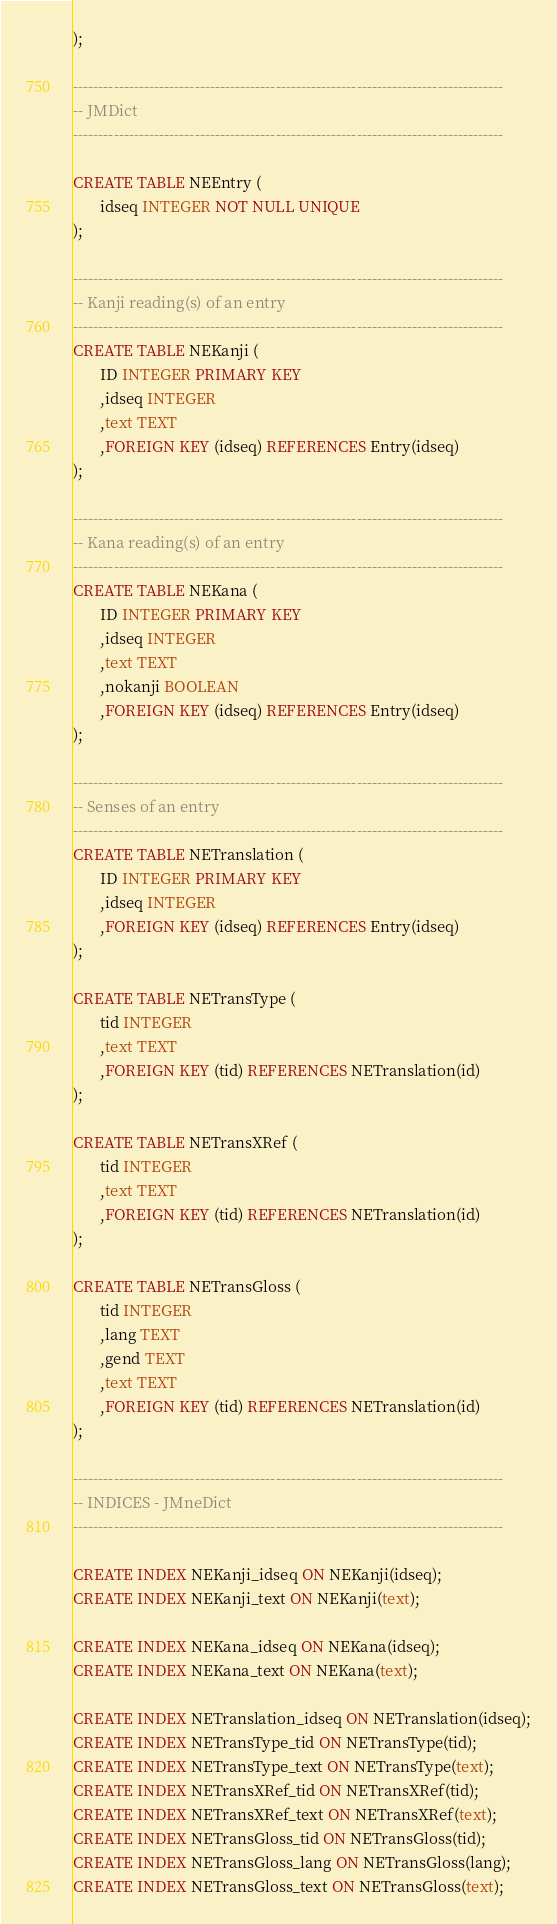Convert code to text. <code><loc_0><loc_0><loc_500><loc_500><_SQL_>);

-------------------------------------------------------------------------------------
-- JMDict
-------------------------------------------------------------------------------------

CREATE TABLE NEEntry (
       idseq INTEGER NOT NULL UNIQUE
);

-------------------------------------------------------------------------------------
-- Kanji reading(s) of an entry
-------------------------------------------------------------------------------------
CREATE TABLE NEKanji (
       ID INTEGER PRIMARY KEY
       ,idseq INTEGER
       ,text TEXT
       ,FOREIGN KEY (idseq) REFERENCES Entry(idseq)
);

-------------------------------------------------------------------------------------
-- Kana reading(s) of an entry
-------------------------------------------------------------------------------------
CREATE TABLE NEKana (
       ID INTEGER PRIMARY KEY
       ,idseq INTEGER
       ,text TEXT
       ,nokanji BOOLEAN
       ,FOREIGN KEY (idseq) REFERENCES Entry(idseq)
);

-------------------------------------------------------------------------------------
-- Senses of an entry
-------------------------------------------------------------------------------------
CREATE TABLE NETranslation (
       ID INTEGER PRIMARY KEY
       ,idseq INTEGER
       ,FOREIGN KEY (idseq) REFERENCES Entry(idseq)
);

CREATE TABLE NETransType (
       tid INTEGER
       ,text TEXT
       ,FOREIGN KEY (tid) REFERENCES NETranslation(id)
);

CREATE TABLE NETransXRef (
       tid INTEGER
       ,text TEXT
       ,FOREIGN KEY (tid) REFERENCES NETranslation(id)
);

CREATE TABLE NETransGloss (
       tid INTEGER
       ,lang TEXT
       ,gend TEXT
       ,text TEXT
       ,FOREIGN KEY (tid) REFERENCES NETranslation(id)
);

-------------------------------------------------------------------------------------
-- INDICES - JMneDict
-------------------------------------------------------------------------------------

CREATE INDEX NEKanji_idseq ON NEKanji(idseq);
CREATE INDEX NEKanji_text ON NEKanji(text);

CREATE INDEX NEKana_idseq ON NEKana(idseq);
CREATE INDEX NEKana_text ON NEKana(text);

CREATE INDEX NETranslation_idseq ON NETranslation(idseq);
CREATE INDEX NETransType_tid ON NETransType(tid);
CREATE INDEX NETransType_text ON NETransType(text);
CREATE INDEX NETransXRef_tid ON NETransXRef(tid);
CREATE INDEX NETransXRef_text ON NETransXRef(text);
CREATE INDEX NETransGloss_tid ON NETransGloss(tid);
CREATE INDEX NETransGloss_lang ON NETransGloss(lang);
CREATE INDEX NETransGloss_text ON NETransGloss(text);

</code> 